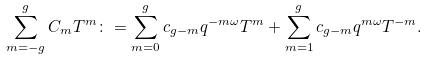Convert formula to latex. <formula><loc_0><loc_0><loc_500><loc_500>\sum _ { m = - g } ^ { g } C _ { m } T ^ { m } \colon = \sum _ { m = 0 } ^ { g } c _ { g - m } q ^ { - m \omega } T ^ { m } + \sum _ { m = 1 } ^ { g } c _ { g - m } q ^ { m \omega } T ^ { - m } .</formula> 